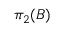<formula> <loc_0><loc_0><loc_500><loc_500>\pi _ { 2 } ( B )</formula> 